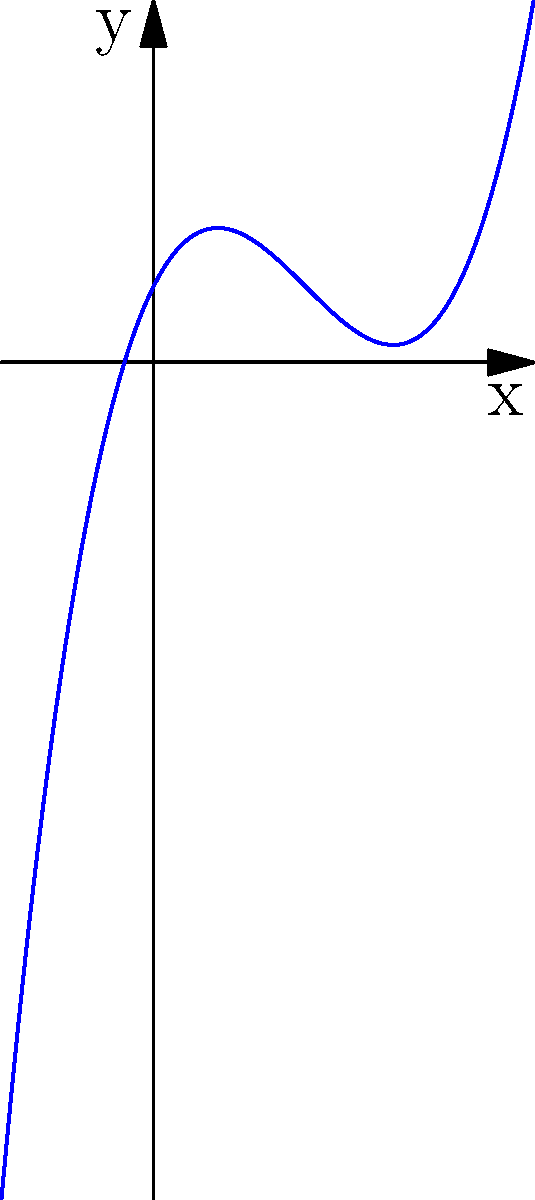Examine the graph above, which represents a polynomial function. Without using modern graphing calculators or computer software, how would you determine the degree of this polynomial based solely on its visual characteristics? To determine the degree of a polynomial from its graph, we should follow these traditional steps:

1. Observe the end behavior: As $x$ approaches positive or negative infinity, how does the function behave?
   - In this case, as $x$ increases, $y$ increases without bound.
   - As $x$ decreases, $y$ decreases without bound.

2. Count the number of turning points (local maxima and minima):
   - This graph has two turning points.

3. Apply the following rules:
   - The degree of a polynomial is at most one more than the number of turning points.
   - For odd degree polynomials, the end behaviors are in opposite directions.
   - For even degree polynomials, the end behaviors are in the same direction.

4. Conclude:
   - With two turning points, the degree could be at most 3.
   - The end behaviors are in opposite directions, indicating an odd degree.
   - Therefore, the polynomial must be of degree 3.
Answer: Degree 3 